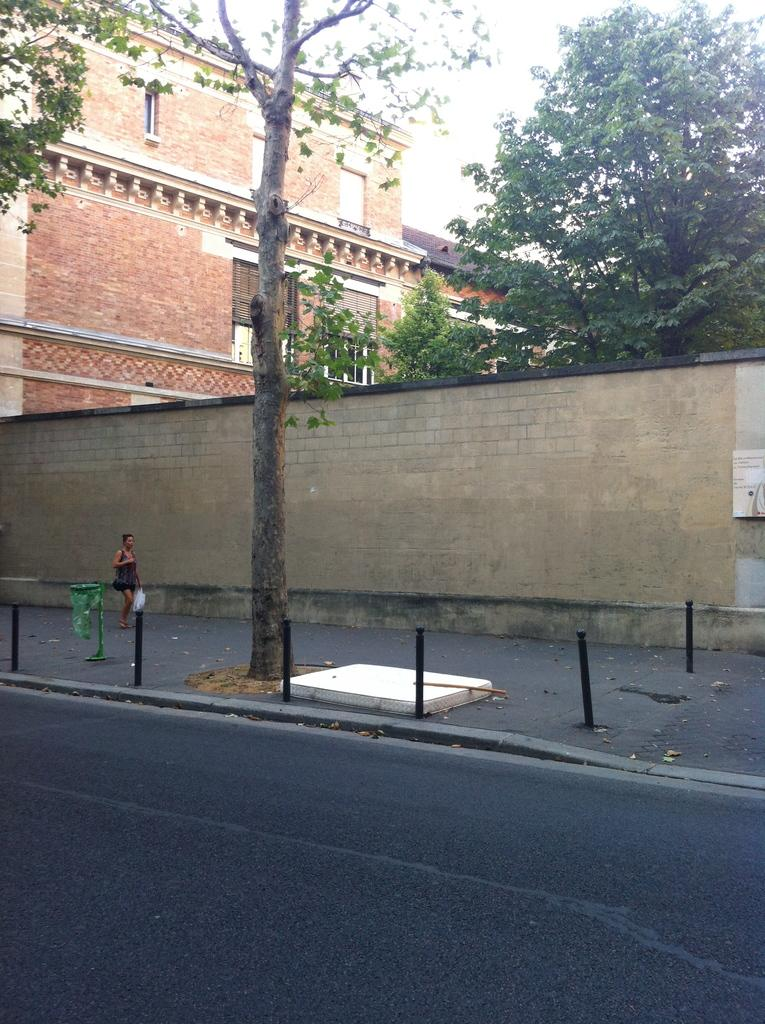Who is the main subject in the foreground of the image? There is a woman in the foreground of the image. Where is the woman located in the image? The woman is on the road. What objects can be seen in the foreground of the image? There are poles and a wall fence in the foreground of the image. What structures are visible in the background of the image? There are buildings and trees in the background of the image. What part of the natural environment is visible in the background of the image? The sky is visible in the background of the image. When was the image taken? The image was taken during the day. What type of religious ceremony is taking place in the image? There is no indication of a religious ceremony in the image; it simply shows a woman on the road with poles and a wall fence in the foreground, and buildings, trees, and the sky in the background. How many zebras can be seen grazing in the yard in the image? There are no zebras present in the image, and there is no yard visible. 